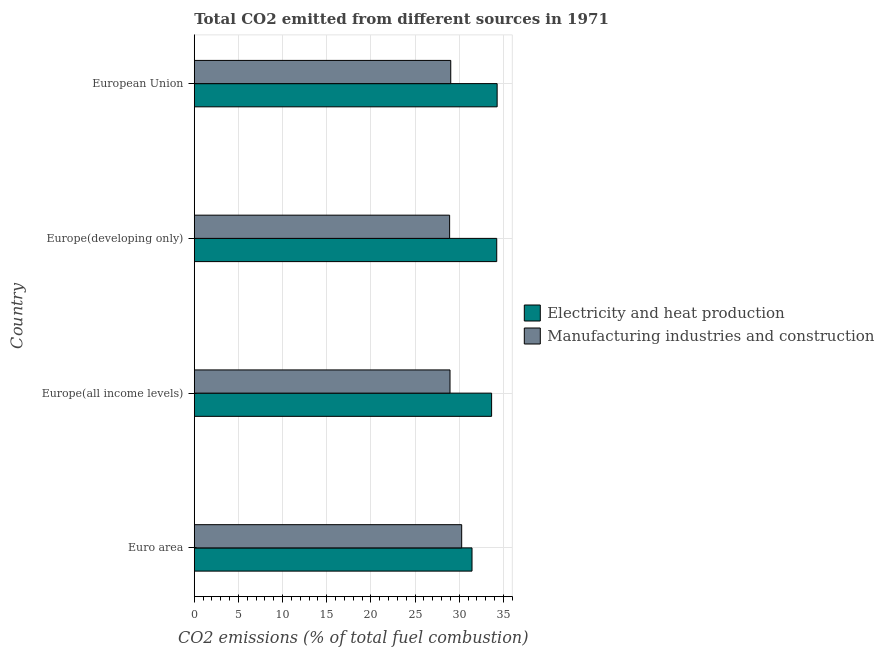How many bars are there on the 3rd tick from the bottom?
Your answer should be very brief. 2. In how many cases, is the number of bars for a given country not equal to the number of legend labels?
Offer a terse response. 0. What is the co2 emissions due to manufacturing industries in Europe(all income levels)?
Your response must be concise. 28.95. Across all countries, what is the maximum co2 emissions due to manufacturing industries?
Make the answer very short. 30.27. Across all countries, what is the minimum co2 emissions due to electricity and heat production?
Provide a succinct answer. 31.44. In which country was the co2 emissions due to electricity and heat production maximum?
Make the answer very short. European Union. What is the total co2 emissions due to manufacturing industries in the graph?
Provide a short and direct response. 117.18. What is the difference between the co2 emissions due to manufacturing industries in Euro area and that in European Union?
Keep it short and to the point. 1.24. What is the difference between the co2 emissions due to manufacturing industries in Europe(developing only) and the co2 emissions due to electricity and heat production in Europe(all income levels)?
Offer a terse response. -4.75. What is the average co2 emissions due to electricity and heat production per country?
Offer a very short reply. 33.41. What is the difference between the co2 emissions due to electricity and heat production and co2 emissions due to manufacturing industries in Europe(all income levels)?
Provide a succinct answer. 4.71. In how many countries, is the co2 emissions due to manufacturing industries greater than 34 %?
Make the answer very short. 0. What is the ratio of the co2 emissions due to electricity and heat production in Europe(all income levels) to that in European Union?
Keep it short and to the point. 0.98. Is the co2 emissions due to electricity and heat production in Euro area less than that in Europe(developing only)?
Ensure brevity in your answer.  Yes. Is the difference between the co2 emissions due to manufacturing industries in Euro area and Europe(developing only) greater than the difference between the co2 emissions due to electricity and heat production in Euro area and Europe(developing only)?
Your response must be concise. Yes. What is the difference between the highest and the second highest co2 emissions due to electricity and heat production?
Your answer should be very brief. 0.05. What is the difference between the highest and the lowest co2 emissions due to electricity and heat production?
Provide a short and direct response. 2.85. In how many countries, is the co2 emissions due to manufacturing industries greater than the average co2 emissions due to manufacturing industries taken over all countries?
Offer a very short reply. 1. Is the sum of the co2 emissions due to electricity and heat production in Europe(all income levels) and Europe(developing only) greater than the maximum co2 emissions due to manufacturing industries across all countries?
Your response must be concise. Yes. What does the 1st bar from the top in Europe(all income levels) represents?
Your response must be concise. Manufacturing industries and construction. What does the 2nd bar from the bottom in European Union represents?
Give a very brief answer. Manufacturing industries and construction. How many bars are there?
Provide a short and direct response. 8. Are all the bars in the graph horizontal?
Provide a succinct answer. Yes. How many countries are there in the graph?
Your answer should be very brief. 4. What is the difference between two consecutive major ticks on the X-axis?
Ensure brevity in your answer.  5. Are the values on the major ticks of X-axis written in scientific E-notation?
Your response must be concise. No. Does the graph contain any zero values?
Ensure brevity in your answer.  No. What is the title of the graph?
Provide a succinct answer. Total CO2 emitted from different sources in 1971. Does "Investment in Transport" appear as one of the legend labels in the graph?
Make the answer very short. No. What is the label or title of the X-axis?
Offer a terse response. CO2 emissions (% of total fuel combustion). What is the label or title of the Y-axis?
Your answer should be very brief. Country. What is the CO2 emissions (% of total fuel combustion) in Electricity and heat production in Euro area?
Give a very brief answer. 31.44. What is the CO2 emissions (% of total fuel combustion) in Manufacturing industries and construction in Euro area?
Give a very brief answer. 30.27. What is the CO2 emissions (% of total fuel combustion) of Electricity and heat production in Europe(all income levels)?
Your answer should be very brief. 33.66. What is the CO2 emissions (% of total fuel combustion) in Manufacturing industries and construction in Europe(all income levels)?
Provide a succinct answer. 28.95. What is the CO2 emissions (% of total fuel combustion) in Electricity and heat production in Europe(developing only)?
Your response must be concise. 34.24. What is the CO2 emissions (% of total fuel combustion) in Manufacturing industries and construction in Europe(developing only)?
Your answer should be compact. 28.91. What is the CO2 emissions (% of total fuel combustion) in Electricity and heat production in European Union?
Offer a very short reply. 34.29. What is the CO2 emissions (% of total fuel combustion) of Manufacturing industries and construction in European Union?
Offer a very short reply. 29.04. Across all countries, what is the maximum CO2 emissions (% of total fuel combustion) of Electricity and heat production?
Provide a short and direct response. 34.29. Across all countries, what is the maximum CO2 emissions (% of total fuel combustion) of Manufacturing industries and construction?
Ensure brevity in your answer.  30.27. Across all countries, what is the minimum CO2 emissions (% of total fuel combustion) in Electricity and heat production?
Ensure brevity in your answer.  31.44. Across all countries, what is the minimum CO2 emissions (% of total fuel combustion) in Manufacturing industries and construction?
Your response must be concise. 28.91. What is the total CO2 emissions (% of total fuel combustion) in Electricity and heat production in the graph?
Offer a terse response. 133.64. What is the total CO2 emissions (% of total fuel combustion) in Manufacturing industries and construction in the graph?
Keep it short and to the point. 117.18. What is the difference between the CO2 emissions (% of total fuel combustion) of Electricity and heat production in Euro area and that in Europe(all income levels)?
Provide a succinct answer. -2.22. What is the difference between the CO2 emissions (% of total fuel combustion) of Manufacturing industries and construction in Euro area and that in Europe(all income levels)?
Give a very brief answer. 1.32. What is the difference between the CO2 emissions (% of total fuel combustion) of Electricity and heat production in Euro area and that in Europe(developing only)?
Provide a succinct answer. -2.8. What is the difference between the CO2 emissions (% of total fuel combustion) in Manufacturing industries and construction in Euro area and that in Europe(developing only)?
Provide a short and direct response. 1.36. What is the difference between the CO2 emissions (% of total fuel combustion) in Electricity and heat production in Euro area and that in European Union?
Offer a terse response. -2.85. What is the difference between the CO2 emissions (% of total fuel combustion) in Manufacturing industries and construction in Euro area and that in European Union?
Offer a very short reply. 1.24. What is the difference between the CO2 emissions (% of total fuel combustion) in Electricity and heat production in Europe(all income levels) and that in Europe(developing only)?
Provide a succinct answer. -0.58. What is the difference between the CO2 emissions (% of total fuel combustion) of Manufacturing industries and construction in Europe(all income levels) and that in Europe(developing only)?
Keep it short and to the point. 0.04. What is the difference between the CO2 emissions (% of total fuel combustion) in Electricity and heat production in Europe(all income levels) and that in European Union?
Your answer should be compact. -0.63. What is the difference between the CO2 emissions (% of total fuel combustion) in Manufacturing industries and construction in Europe(all income levels) and that in European Union?
Provide a short and direct response. -0.08. What is the difference between the CO2 emissions (% of total fuel combustion) in Electricity and heat production in Europe(developing only) and that in European Union?
Your answer should be compact. -0.05. What is the difference between the CO2 emissions (% of total fuel combustion) of Manufacturing industries and construction in Europe(developing only) and that in European Union?
Make the answer very short. -0.13. What is the difference between the CO2 emissions (% of total fuel combustion) of Electricity and heat production in Euro area and the CO2 emissions (% of total fuel combustion) of Manufacturing industries and construction in Europe(all income levels)?
Ensure brevity in your answer.  2.49. What is the difference between the CO2 emissions (% of total fuel combustion) in Electricity and heat production in Euro area and the CO2 emissions (% of total fuel combustion) in Manufacturing industries and construction in Europe(developing only)?
Make the answer very short. 2.53. What is the difference between the CO2 emissions (% of total fuel combustion) in Electricity and heat production in Euro area and the CO2 emissions (% of total fuel combustion) in Manufacturing industries and construction in European Union?
Your response must be concise. 2.41. What is the difference between the CO2 emissions (% of total fuel combustion) of Electricity and heat production in Europe(all income levels) and the CO2 emissions (% of total fuel combustion) of Manufacturing industries and construction in Europe(developing only)?
Offer a terse response. 4.75. What is the difference between the CO2 emissions (% of total fuel combustion) of Electricity and heat production in Europe(all income levels) and the CO2 emissions (% of total fuel combustion) of Manufacturing industries and construction in European Union?
Your answer should be compact. 4.63. What is the difference between the CO2 emissions (% of total fuel combustion) of Electricity and heat production in Europe(developing only) and the CO2 emissions (% of total fuel combustion) of Manufacturing industries and construction in European Union?
Your answer should be very brief. 5.21. What is the average CO2 emissions (% of total fuel combustion) in Electricity and heat production per country?
Your answer should be very brief. 33.41. What is the average CO2 emissions (% of total fuel combustion) in Manufacturing industries and construction per country?
Your answer should be very brief. 29.29. What is the difference between the CO2 emissions (% of total fuel combustion) in Electricity and heat production and CO2 emissions (% of total fuel combustion) in Manufacturing industries and construction in Euro area?
Your response must be concise. 1.17. What is the difference between the CO2 emissions (% of total fuel combustion) in Electricity and heat production and CO2 emissions (% of total fuel combustion) in Manufacturing industries and construction in Europe(all income levels)?
Offer a very short reply. 4.71. What is the difference between the CO2 emissions (% of total fuel combustion) in Electricity and heat production and CO2 emissions (% of total fuel combustion) in Manufacturing industries and construction in Europe(developing only)?
Make the answer very short. 5.33. What is the difference between the CO2 emissions (% of total fuel combustion) of Electricity and heat production and CO2 emissions (% of total fuel combustion) of Manufacturing industries and construction in European Union?
Your response must be concise. 5.25. What is the ratio of the CO2 emissions (% of total fuel combustion) in Electricity and heat production in Euro area to that in Europe(all income levels)?
Provide a succinct answer. 0.93. What is the ratio of the CO2 emissions (% of total fuel combustion) in Manufacturing industries and construction in Euro area to that in Europe(all income levels)?
Your response must be concise. 1.05. What is the ratio of the CO2 emissions (% of total fuel combustion) of Electricity and heat production in Euro area to that in Europe(developing only)?
Give a very brief answer. 0.92. What is the ratio of the CO2 emissions (% of total fuel combustion) in Manufacturing industries and construction in Euro area to that in Europe(developing only)?
Provide a short and direct response. 1.05. What is the ratio of the CO2 emissions (% of total fuel combustion) of Electricity and heat production in Euro area to that in European Union?
Your answer should be very brief. 0.92. What is the ratio of the CO2 emissions (% of total fuel combustion) of Manufacturing industries and construction in Euro area to that in European Union?
Offer a very short reply. 1.04. What is the ratio of the CO2 emissions (% of total fuel combustion) of Electricity and heat production in Europe(all income levels) to that in Europe(developing only)?
Your response must be concise. 0.98. What is the ratio of the CO2 emissions (% of total fuel combustion) in Manufacturing industries and construction in Europe(all income levels) to that in Europe(developing only)?
Your response must be concise. 1. What is the ratio of the CO2 emissions (% of total fuel combustion) of Electricity and heat production in Europe(all income levels) to that in European Union?
Ensure brevity in your answer.  0.98. What is the ratio of the CO2 emissions (% of total fuel combustion) in Manufacturing industries and construction in Europe(all income levels) to that in European Union?
Your answer should be very brief. 1. What is the ratio of the CO2 emissions (% of total fuel combustion) in Electricity and heat production in Europe(developing only) to that in European Union?
Make the answer very short. 1. What is the difference between the highest and the second highest CO2 emissions (% of total fuel combustion) in Electricity and heat production?
Provide a short and direct response. 0.05. What is the difference between the highest and the second highest CO2 emissions (% of total fuel combustion) of Manufacturing industries and construction?
Give a very brief answer. 1.24. What is the difference between the highest and the lowest CO2 emissions (% of total fuel combustion) in Electricity and heat production?
Ensure brevity in your answer.  2.85. What is the difference between the highest and the lowest CO2 emissions (% of total fuel combustion) of Manufacturing industries and construction?
Give a very brief answer. 1.36. 